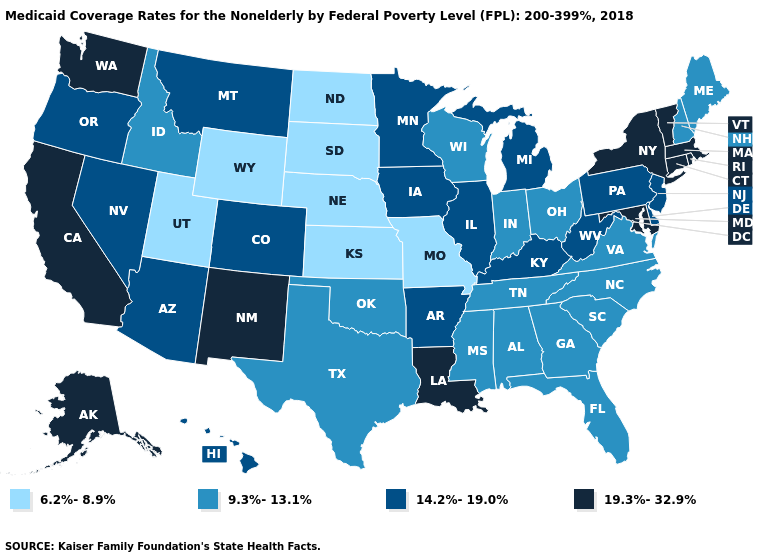Does the first symbol in the legend represent the smallest category?
Be succinct. Yes. Does Oklahoma have the same value as Louisiana?
Short answer required. No. Name the states that have a value in the range 9.3%-13.1%?
Give a very brief answer. Alabama, Florida, Georgia, Idaho, Indiana, Maine, Mississippi, New Hampshire, North Carolina, Ohio, Oklahoma, South Carolina, Tennessee, Texas, Virginia, Wisconsin. What is the lowest value in states that border Oklahoma?
Concise answer only. 6.2%-8.9%. What is the value of Mississippi?
Quick response, please. 9.3%-13.1%. Which states have the lowest value in the Northeast?
Write a very short answer. Maine, New Hampshire. What is the value of Nebraska?
Short answer required. 6.2%-8.9%. Name the states that have a value in the range 14.2%-19.0%?
Be succinct. Arizona, Arkansas, Colorado, Delaware, Hawaii, Illinois, Iowa, Kentucky, Michigan, Minnesota, Montana, Nevada, New Jersey, Oregon, Pennsylvania, West Virginia. Among the states that border Indiana , which have the highest value?
Give a very brief answer. Illinois, Kentucky, Michigan. Among the states that border Louisiana , which have the highest value?
Short answer required. Arkansas. Name the states that have a value in the range 19.3%-32.9%?
Keep it brief. Alaska, California, Connecticut, Louisiana, Maryland, Massachusetts, New Mexico, New York, Rhode Island, Vermont, Washington. Name the states that have a value in the range 9.3%-13.1%?
Quick response, please. Alabama, Florida, Georgia, Idaho, Indiana, Maine, Mississippi, New Hampshire, North Carolina, Ohio, Oklahoma, South Carolina, Tennessee, Texas, Virginia, Wisconsin. What is the value of Utah?
Keep it brief. 6.2%-8.9%. Among the states that border Texas , does Oklahoma have the highest value?
Be succinct. No. 